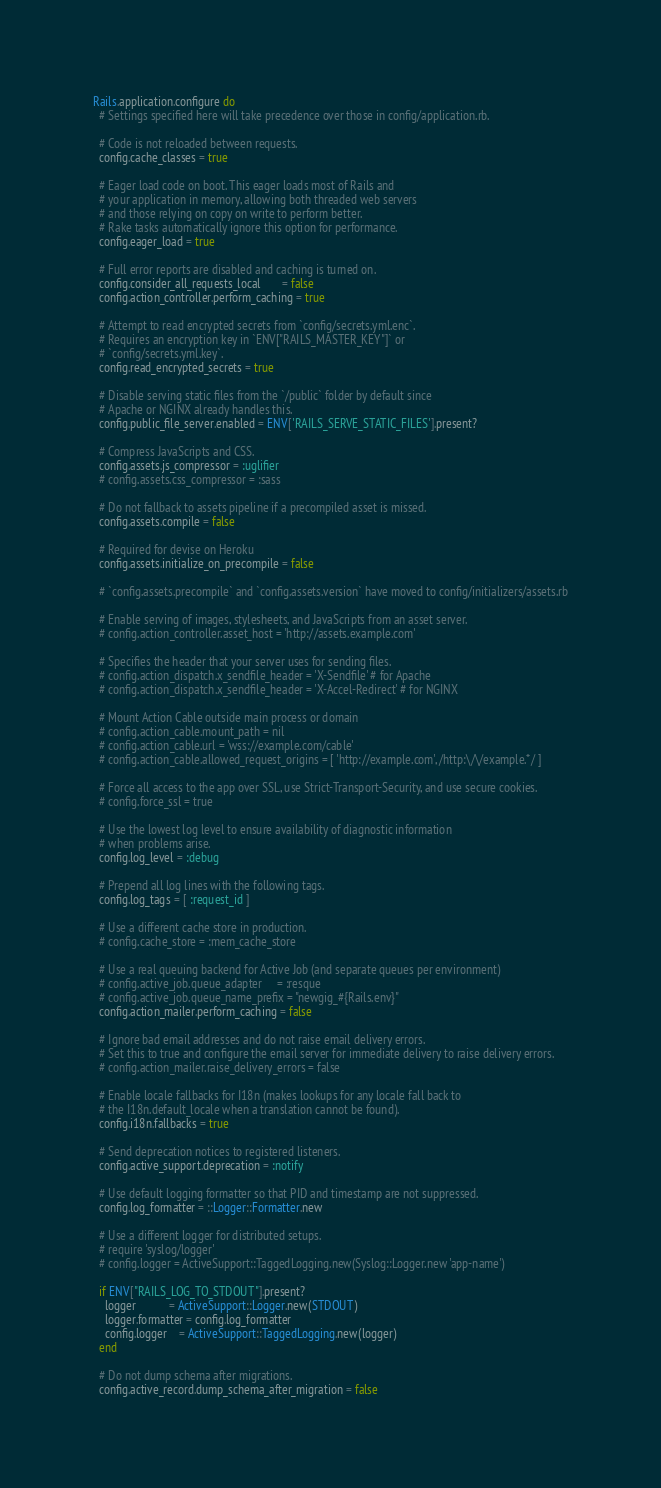Convert code to text. <code><loc_0><loc_0><loc_500><loc_500><_Ruby_>Rails.application.configure do
  # Settings specified here will take precedence over those in config/application.rb.

  # Code is not reloaded between requests.
  config.cache_classes = true

  # Eager load code on boot. This eager loads most of Rails and
  # your application in memory, allowing both threaded web servers
  # and those relying on copy on write to perform better.
  # Rake tasks automatically ignore this option for performance.
  config.eager_load = true

  # Full error reports are disabled and caching is turned on.
  config.consider_all_requests_local       = false
  config.action_controller.perform_caching = true

  # Attempt to read encrypted secrets from `config/secrets.yml.enc`.
  # Requires an encryption key in `ENV["RAILS_MASTER_KEY"]` or
  # `config/secrets.yml.key`.
  config.read_encrypted_secrets = true

  # Disable serving static files from the `/public` folder by default since
  # Apache or NGINX already handles this.
  config.public_file_server.enabled = ENV['RAILS_SERVE_STATIC_FILES'].present?

  # Compress JavaScripts and CSS.
  config.assets.js_compressor = :uglifier
  # config.assets.css_compressor = :sass

  # Do not fallback to assets pipeline if a precompiled asset is missed.
  config.assets.compile = false

  # Required for devise on Heroku
  config.assets.initialize_on_precompile = false

  # `config.assets.precompile` and `config.assets.version` have moved to config/initializers/assets.rb

  # Enable serving of images, stylesheets, and JavaScripts from an asset server.
  # config.action_controller.asset_host = 'http://assets.example.com'

  # Specifies the header that your server uses for sending files.
  # config.action_dispatch.x_sendfile_header = 'X-Sendfile' # for Apache
  # config.action_dispatch.x_sendfile_header = 'X-Accel-Redirect' # for NGINX

  # Mount Action Cable outside main process or domain
  # config.action_cable.mount_path = nil
  # config.action_cable.url = 'wss://example.com/cable'
  # config.action_cable.allowed_request_origins = [ 'http://example.com', /http:\/\/example.*/ ]

  # Force all access to the app over SSL, use Strict-Transport-Security, and use secure cookies.
  # config.force_ssl = true

  # Use the lowest log level to ensure availability of diagnostic information
  # when problems arise.
  config.log_level = :debug

  # Prepend all log lines with the following tags.
  config.log_tags = [ :request_id ]

  # Use a different cache store in production.
  # config.cache_store = :mem_cache_store

  # Use a real queuing backend for Active Job (and separate queues per environment)
  # config.active_job.queue_adapter     = :resque
  # config.active_job.queue_name_prefix = "newgig_#{Rails.env}"
  config.action_mailer.perform_caching = false

  # Ignore bad email addresses and do not raise email delivery errors.
  # Set this to true and configure the email server for immediate delivery to raise delivery errors.
  # config.action_mailer.raise_delivery_errors = false

  # Enable locale fallbacks for I18n (makes lookups for any locale fall back to
  # the I18n.default_locale when a translation cannot be found).
  config.i18n.fallbacks = true

  # Send deprecation notices to registered listeners.
  config.active_support.deprecation = :notify

  # Use default logging formatter so that PID and timestamp are not suppressed.
  config.log_formatter = ::Logger::Formatter.new

  # Use a different logger for distributed setups.
  # require 'syslog/logger'
  # config.logger = ActiveSupport::TaggedLogging.new(Syslog::Logger.new 'app-name')

  if ENV["RAILS_LOG_TO_STDOUT"].present?
    logger           = ActiveSupport::Logger.new(STDOUT)
    logger.formatter = config.log_formatter
    config.logger    = ActiveSupport::TaggedLogging.new(logger)
  end

  # Do not dump schema after migrations.
  config.active_record.dump_schema_after_migration = false
</code> 